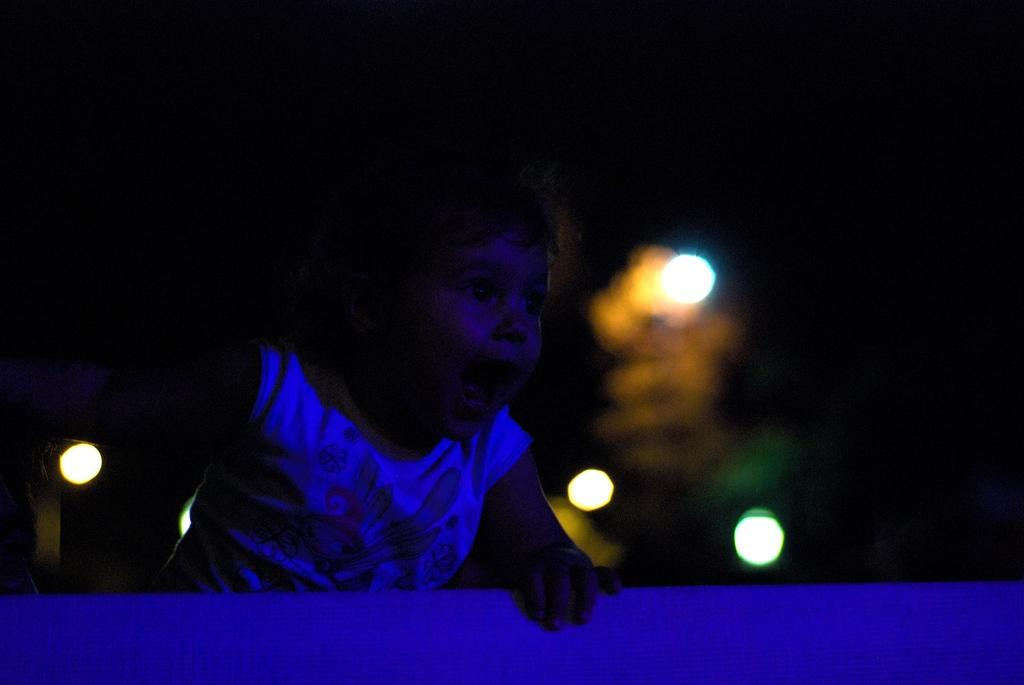What is the main subject of the image? The main subject of the image is a kid. What can be seen in the background of the image? There are lights in the background of the image. What type of air attack is happening in the image? There is no air attack present in the image; it features a kid and lights in the background. Can you tell me how many needles are visible in the image? There are no needles visible in the image. 